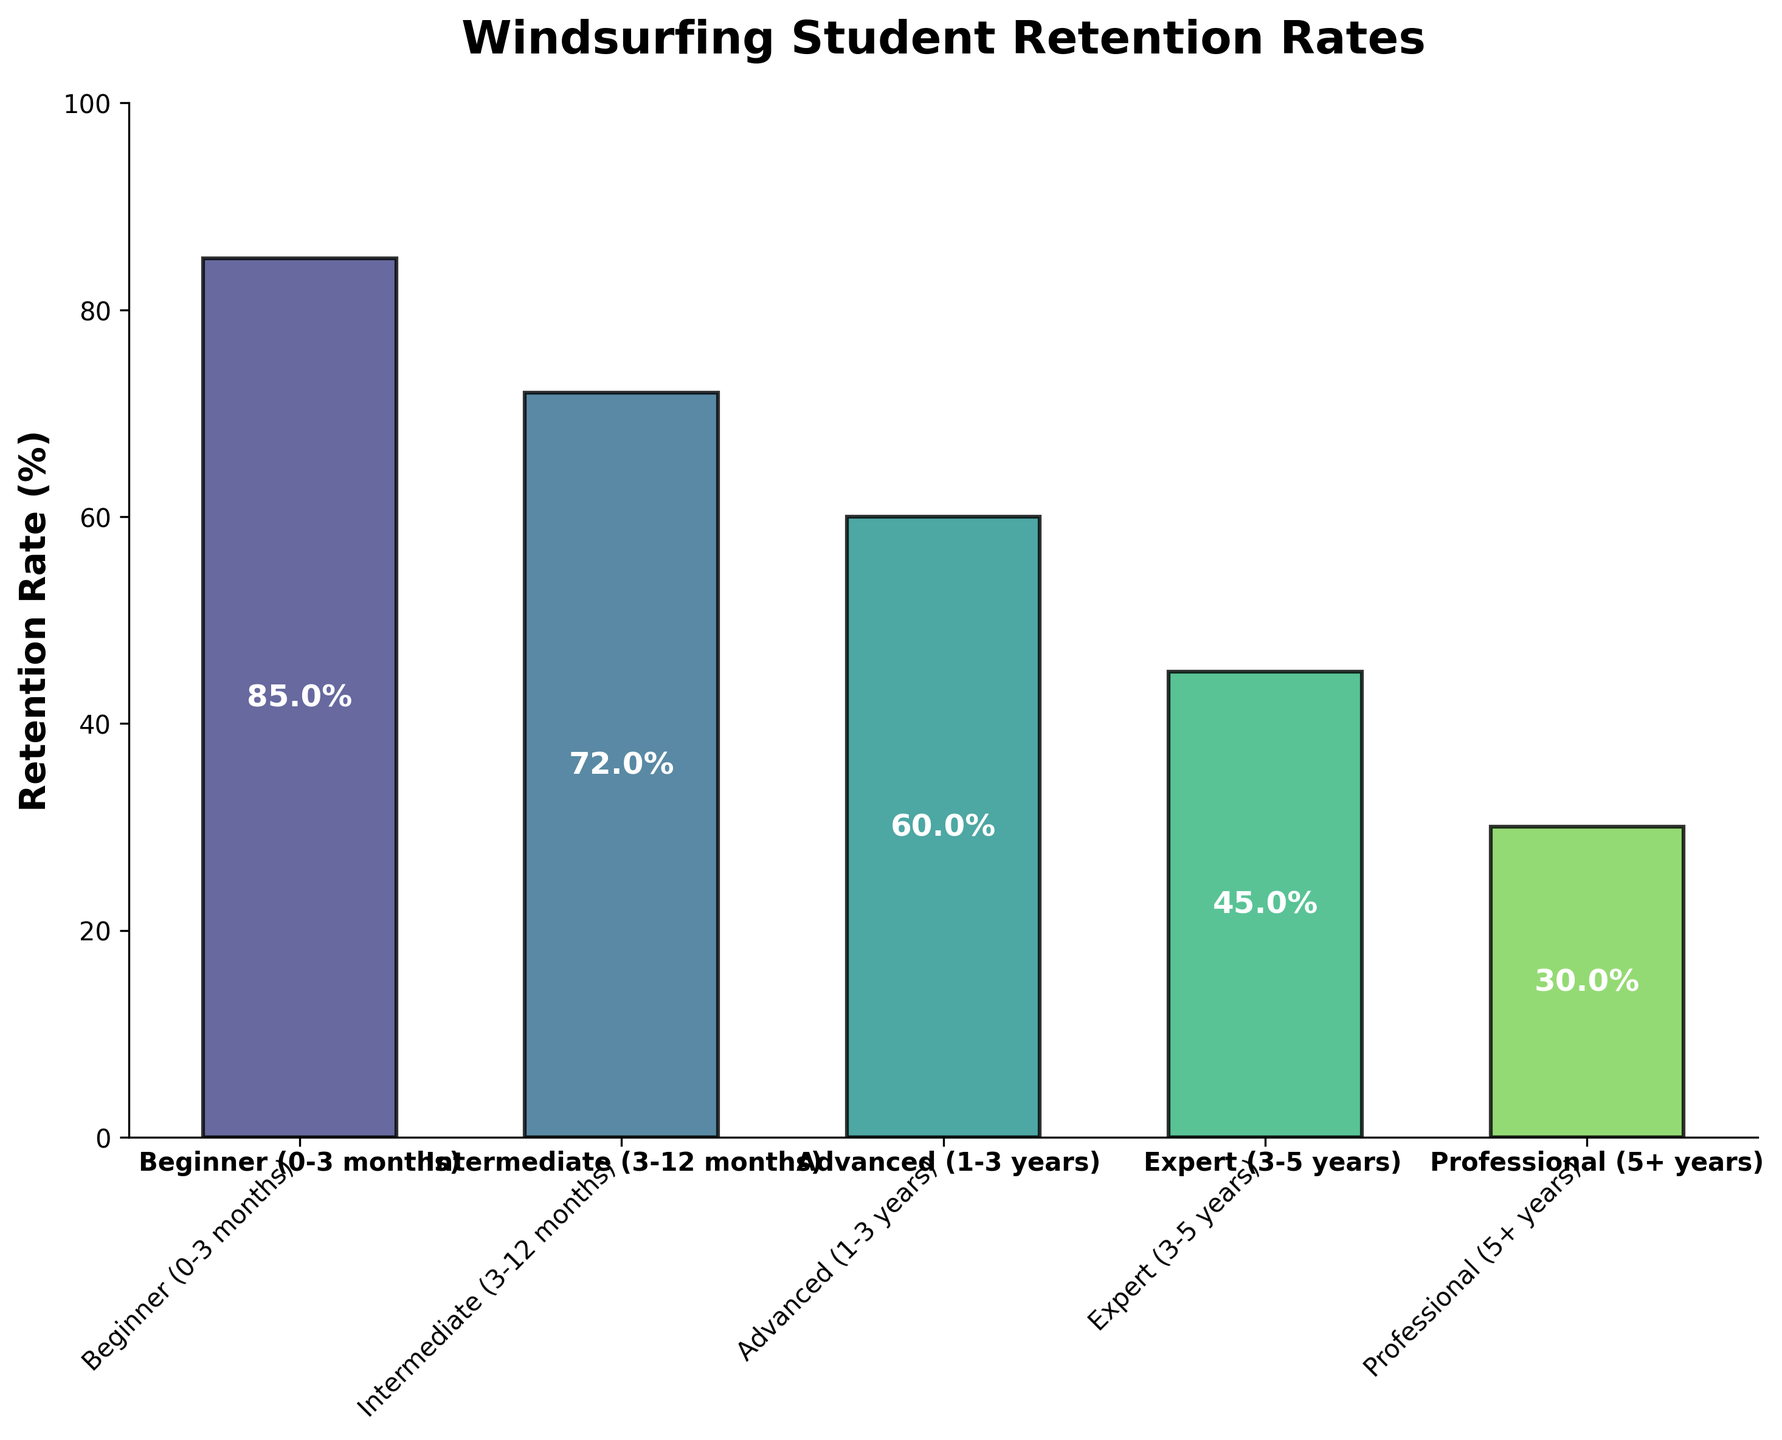Which experience level has the highest retention rate? The figure shows the retention rates of different experience levels, with the highest bar representing the Beginner level.
Answer: Beginner (0-3 months) What is the title of the figure? The title is located at the top center of the figure and reads, "Windsurfing Student Retention Rates."
Answer: Windsurfing Student Retention Rates How many experience levels are shown in the figure? There are five bars in the figure, each representing a different experience level.
Answer: Five What is the retention rate for the Expert level? By identifying the bar labeled Expert (3-5 years) and reading its value, we see that the retention rate is 45%.
Answer: 45% Which experience level has the lowest retention rate? By comparing the heights of all the bars, the Professional (5+ years) level is the shortest, indicating it has the lowest retention rate.
Answer: Professional (5+ years) What is the average retention rate across all experience levels? Adding the retention rates (85%, 72%, 60%, 45%, 30%) gives 292%. Dividing by the number of levels (5) gives an average: 292 / 5 = 58.4%.
Answer: 58.4% How much higher is the Beginner retention rate compared to the Professional level? Subtract the retention rate of the Professional level (30%) from the Beginner level (85%): 85% - 30% = 55%.
Answer: 55% Is the retention rate for Intermediates closer to that of Beginners or that of Advanced learners? The retention rate for Intermediates is 72%. For Beginners, it's 85%, a difference of 85% - 72% = 13%. For Advanced, it is 60%, a difference of 72% - 60% = 12%. Since 12% is smaller than 13%, it's closer to Advanced.
Answer: Advanced (1-3 years) What’s the combined retention rate for the Advanced and Expert levels? Adding the retention rates of the Advanced (60%) and Expert (45%) levels: 60% + 45% = 105%.
Answer: 105% Which experience levels have retention rates greater than 50%? By examining the bars, the retention rates higher than 50% are for Beginner (85%), Intermediate (72%), and Advanced (60%).
Answer: Beginner (0-3 months), Intermediate (3-12 months), Advanced (1-3 years) 